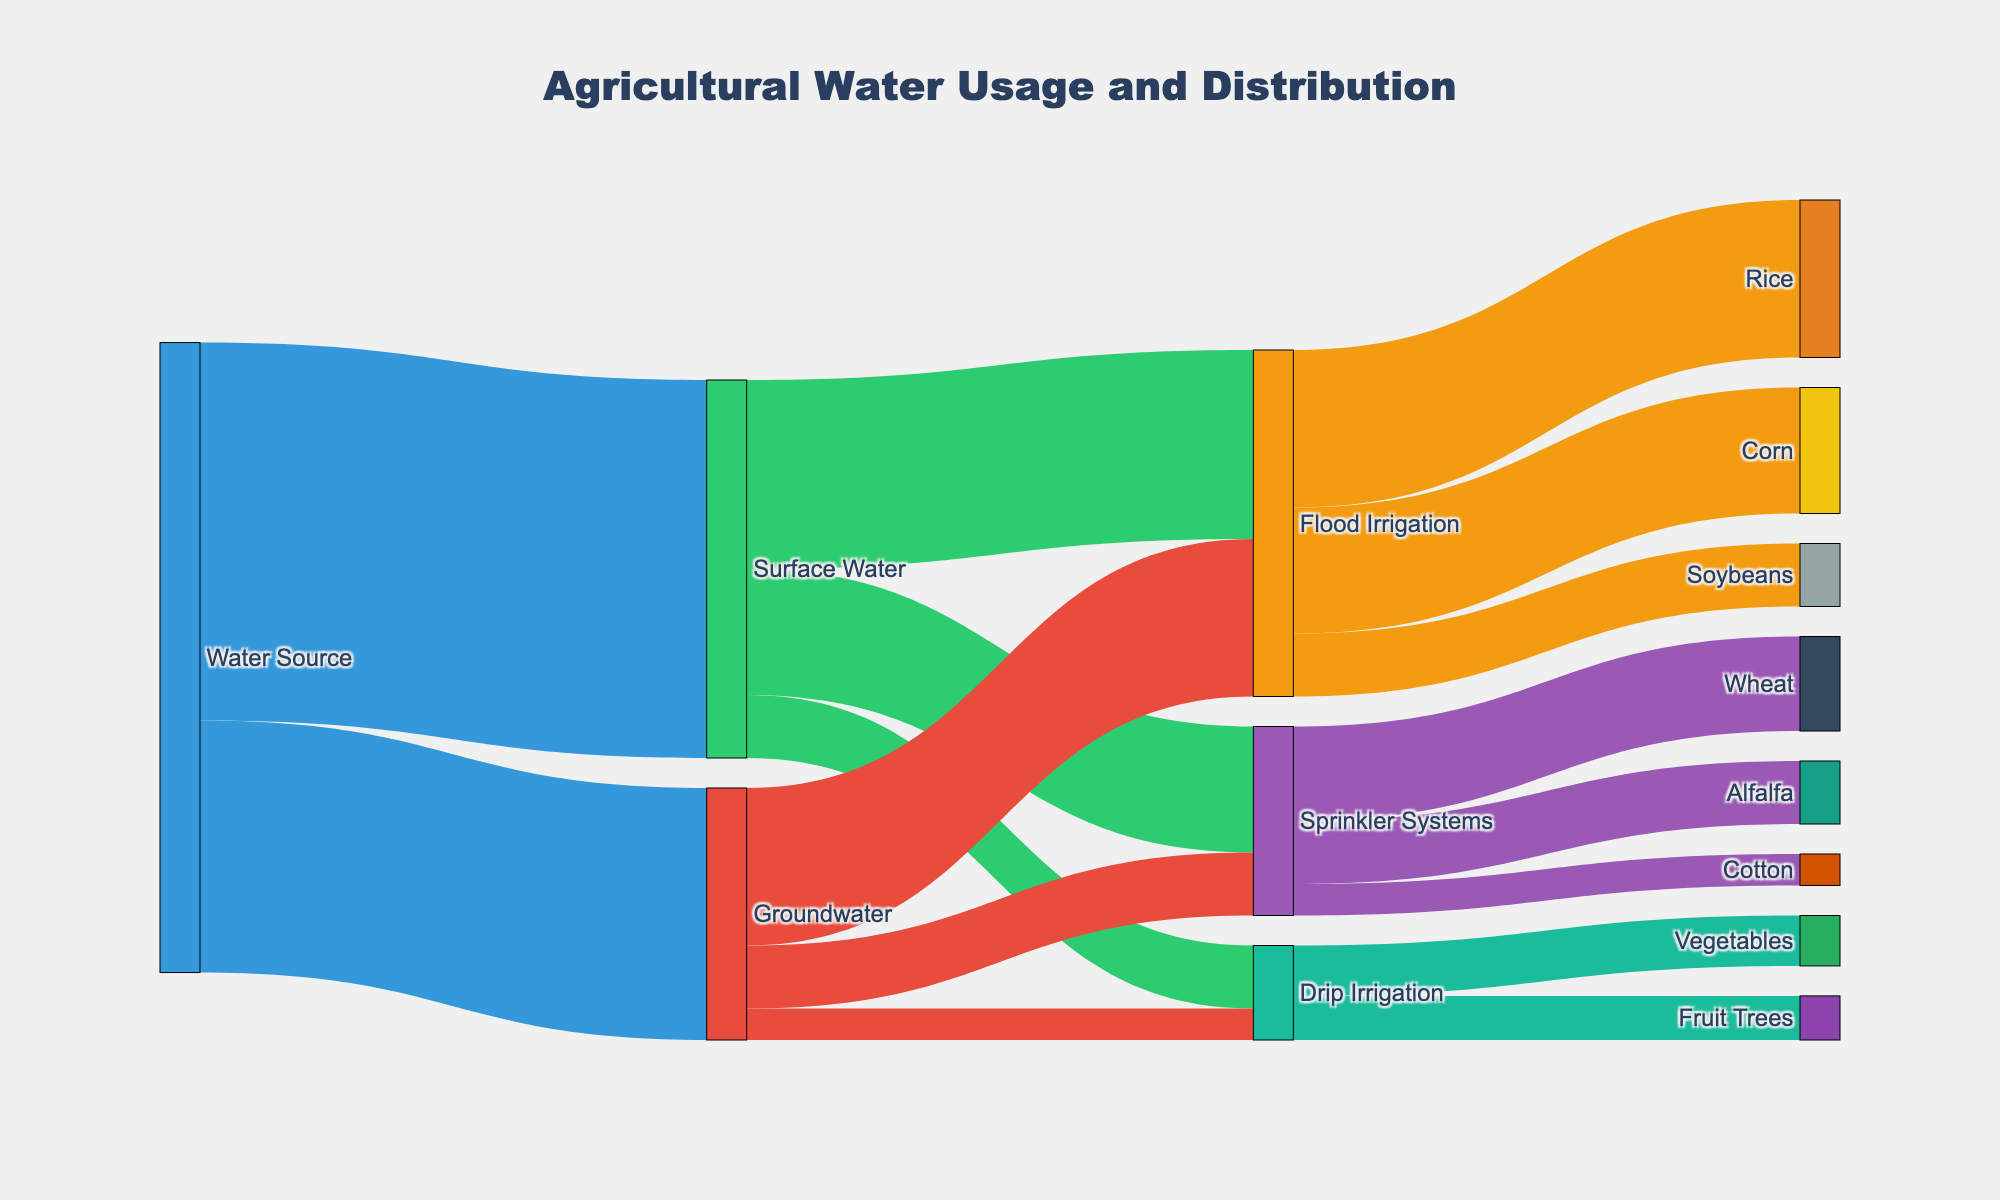What's the main water source for agricultural irrigation? Based on the diagram, the main water source has the largest flow into the irrigation methods. Surface Water has a higher value compared to Groundwater.
Answer: Surface Water Which irrigation method uses the most water from Surface Water? Looking at the flows from Surface Water to the different irrigation methods, the largest value goes to Flood Irrigation.
Answer: Flood Irrigation What is the total amount of water used for Drip Irrigation? The water for Drip Irrigation comes from both Surface Water and Groundwater. The values are 10 from Surface Water and 5 from Groundwater, totaling 15.
Answer: 15 Which crop receives the most water through Flood Irrigation? Checking the flows from Flood Irrigation to different crops, Rice receives the highest amount of water.
Answer: Rice How much total water is used by Sprinkler Systems? Summing the values from Surface Water and Groundwater to Sprinkler Systems, we get 20 from Surface Water and 10 from Groundwater, totaling 30.
Answer: 30 Which water source has a higher distribution to Corn? Corn receives water only from Flood Irrigation. Flood Irrigation gets water from both Surface Water and Groundwater, so we need to compare these. Surface Water provides 30 and Groundwater provides 25. For Corn specifically, this portion is not clear but taking overall distribution for Flood Irrigation, Surface Water has a higher share.
Answer: Surface Water What proportion of Groundwater is used for Sprinkler Systems? From the diagram, Sprinkler Systems receive 10 units from Groundwater, while the total amount of Groundwater is 40. The proportion is \( \frac{10}{40} = \frac{1}{4} \) or 25%.
Answer: 25% Which crop gets water only from one type of irrigation method? By examining the connections from the irrigation methods to the crops, Vegetables and Fruit Trees only connect to Drip Irrigation.
Answer: Vegetables, Fruit Trees What's the combined amount of water used for Wheat and Alfalfa? Both of these crops are irrigated by Sprinkler Systems. Wheat uses 15 units and Alfalfa uses 10 units of water. The combined amount is \( 15 + 10 = 25 \).
Answer: 25 Comparing Surface Water and Groundwater usage for Drip Irrigation, which one is lesser? The diagram shows the values from both sources to Drip Irrigation. Surface Water provides 10 units and Groundwater provides 5 units. Groundwater's contribution is lesser.
Answer: Groundwater 